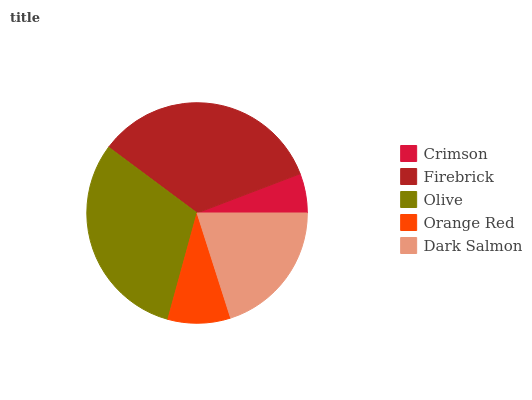Is Crimson the minimum?
Answer yes or no. Yes. Is Firebrick the maximum?
Answer yes or no. Yes. Is Olive the minimum?
Answer yes or no. No. Is Olive the maximum?
Answer yes or no. No. Is Firebrick greater than Olive?
Answer yes or no. Yes. Is Olive less than Firebrick?
Answer yes or no. Yes. Is Olive greater than Firebrick?
Answer yes or no. No. Is Firebrick less than Olive?
Answer yes or no. No. Is Dark Salmon the high median?
Answer yes or no. Yes. Is Dark Salmon the low median?
Answer yes or no. Yes. Is Firebrick the high median?
Answer yes or no. No. Is Olive the low median?
Answer yes or no. No. 